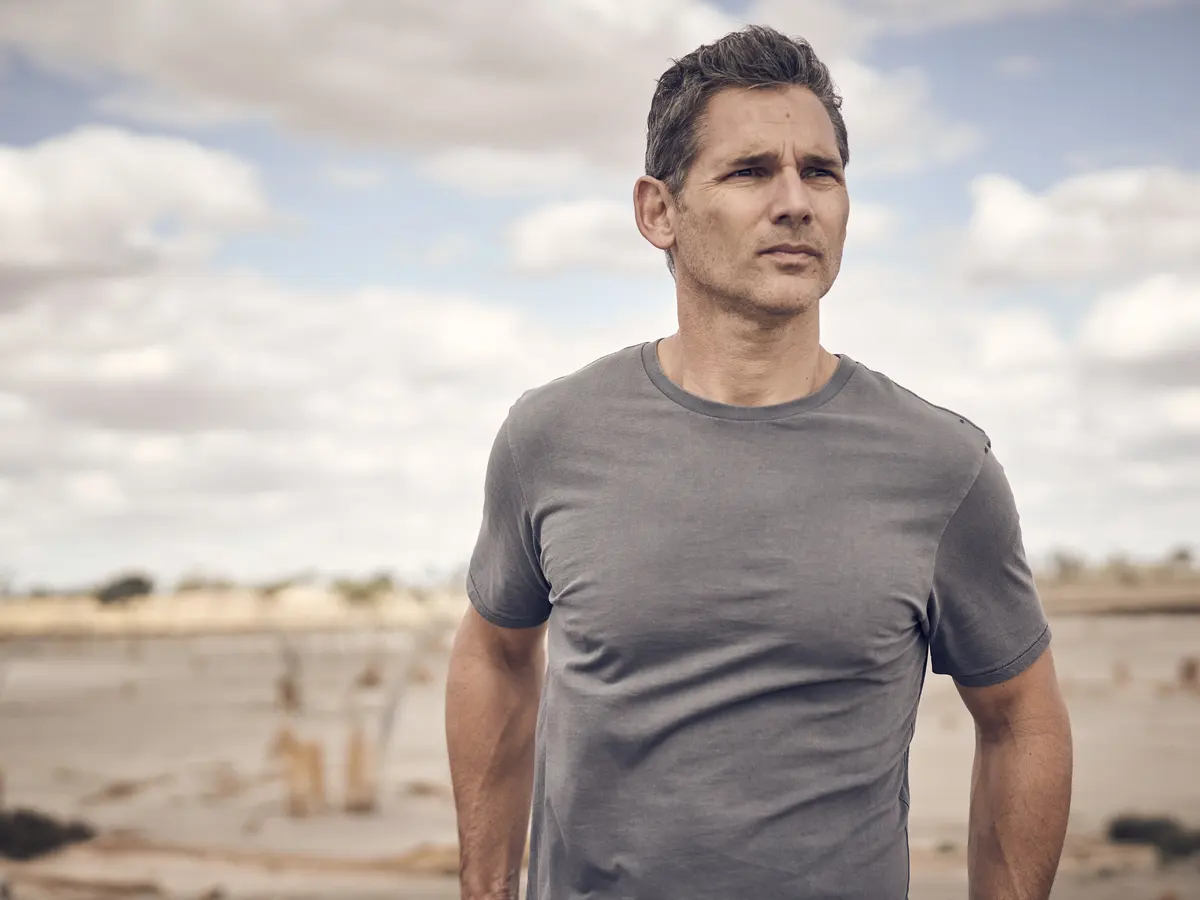What might the person in the image be thinking about? The person in the image might be reflecting on personal thoughts or memories. The contemplative expression and distant gaze suggest he is lost in thought, possibly pondering a significant decision or recalling a heartfelt moment. The serene and solitary beach setting provides a perfect backdrop for such introspection. 